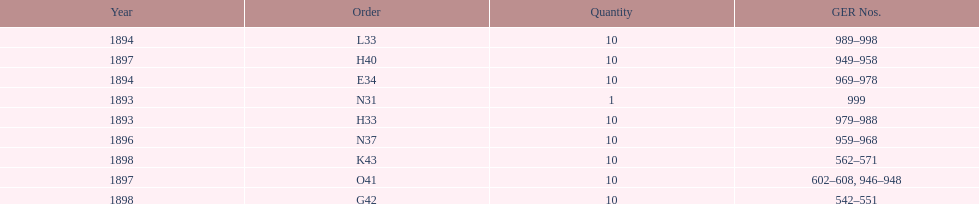How mans years have ger nos below 900? 2. 